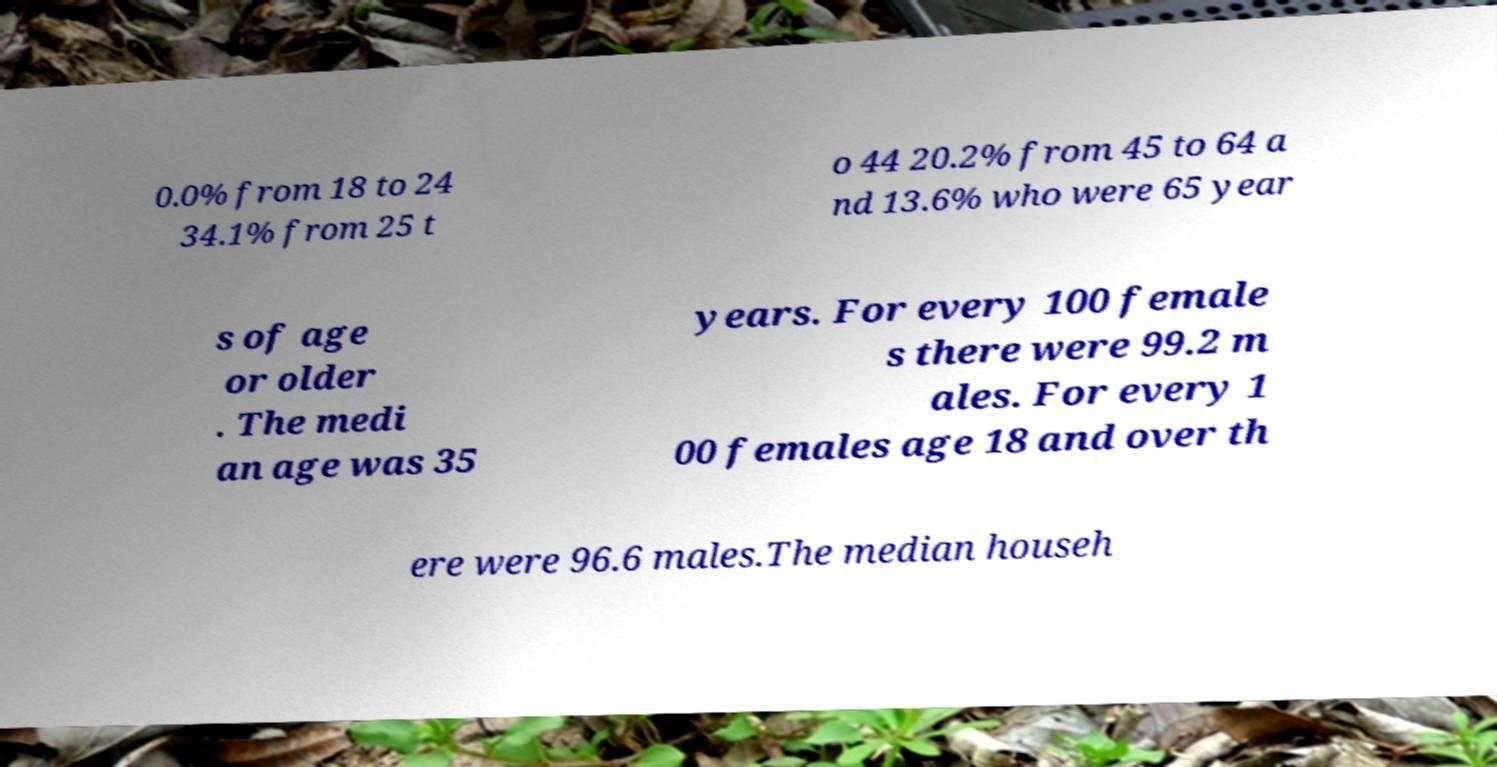I need the written content from this picture converted into text. Can you do that? 0.0% from 18 to 24 34.1% from 25 t o 44 20.2% from 45 to 64 a nd 13.6% who were 65 year s of age or older . The medi an age was 35 years. For every 100 female s there were 99.2 m ales. For every 1 00 females age 18 and over th ere were 96.6 males.The median househ 